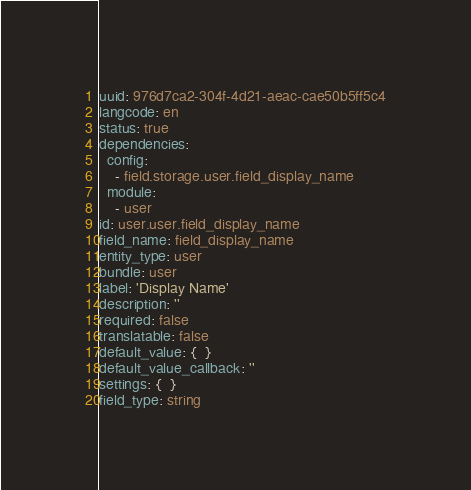Convert code to text. <code><loc_0><loc_0><loc_500><loc_500><_YAML_>uuid: 976d7ca2-304f-4d21-aeac-cae50b5ff5c4
langcode: en
status: true
dependencies:
  config:
    - field.storage.user.field_display_name
  module:
    - user
id: user.user.field_display_name
field_name: field_display_name
entity_type: user
bundle: user
label: 'Display Name'
description: ''
required: false
translatable: false
default_value: {  }
default_value_callback: ''
settings: {  }
field_type: string
</code> 